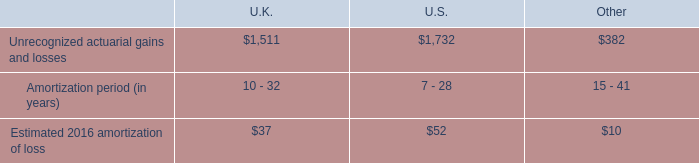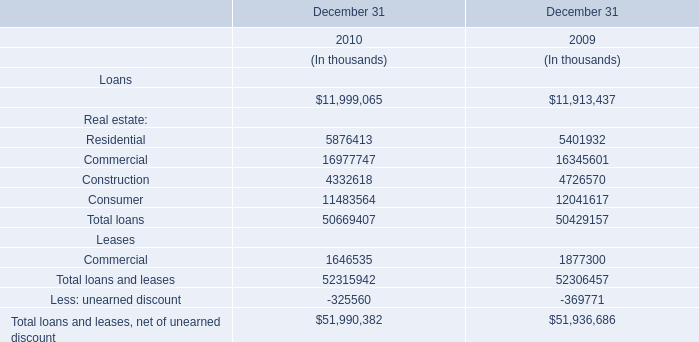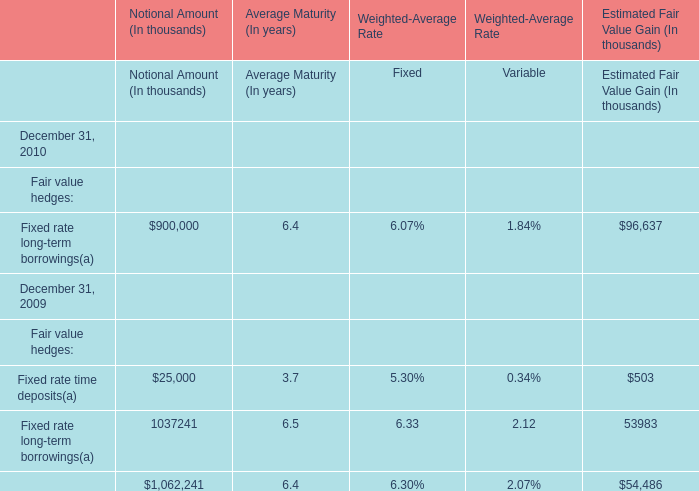what is the total estimated amortization loss for 2016? 
Computations: ((37 + 52) + 10)
Answer: 99.0. 